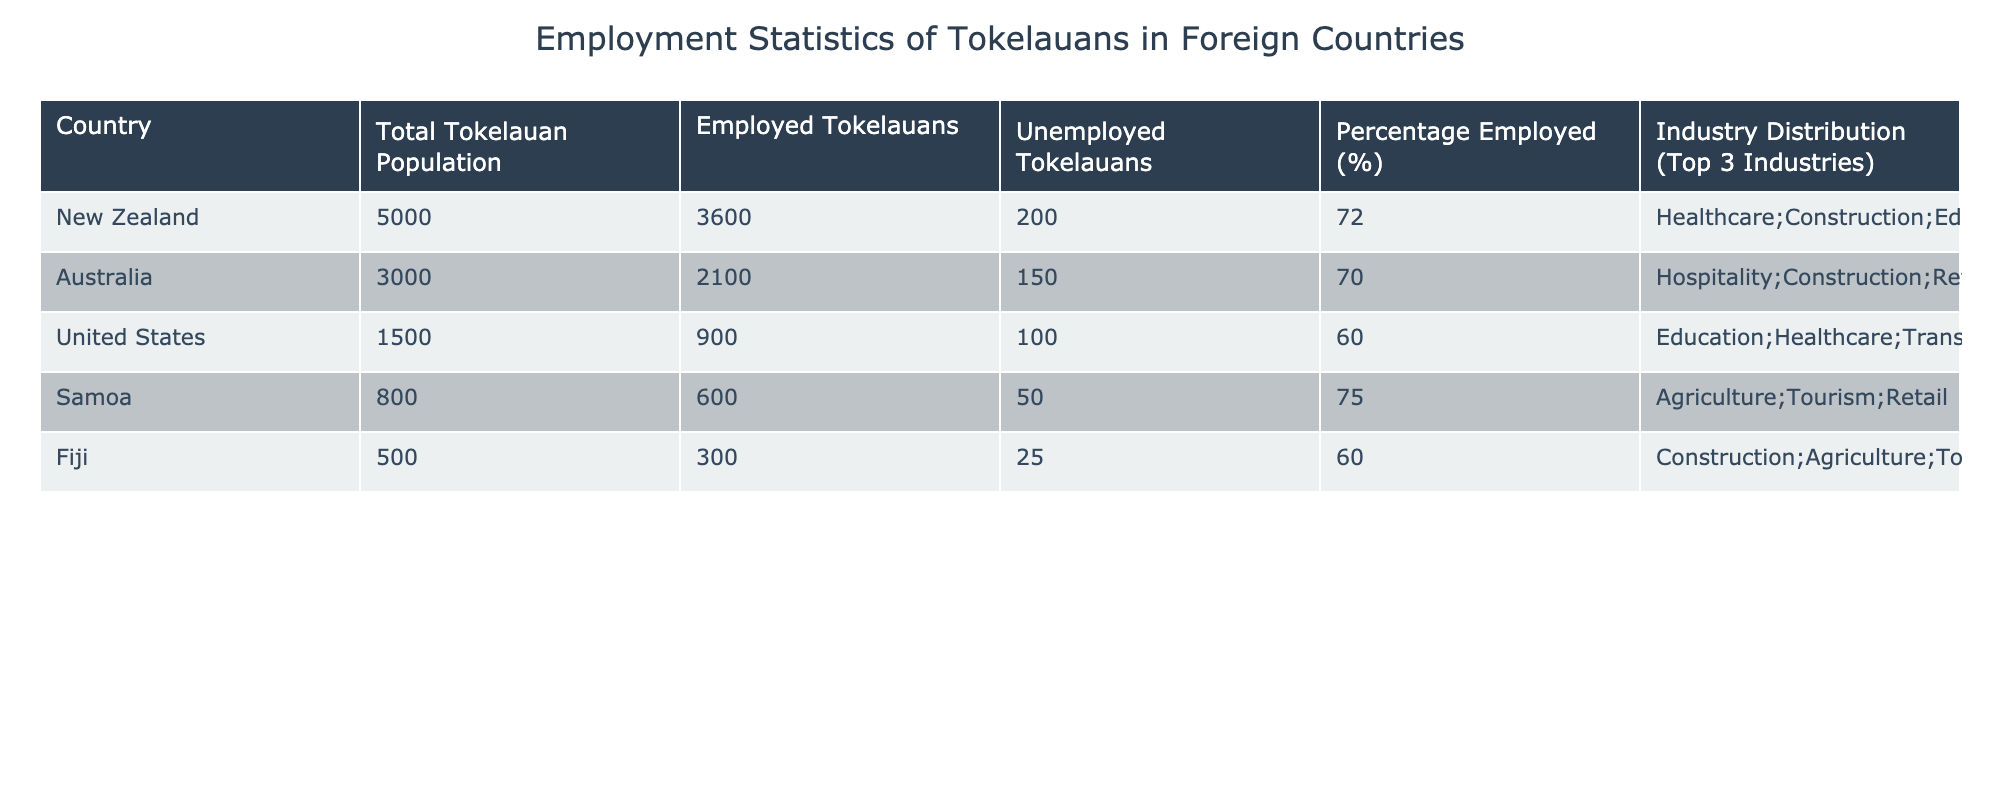What is the employment percentage of Tokelauans in New Zealand? The table shows the employment percentage of Tokelauans in New Zealand as 72%. This value can be directly retrieved from the table under the "Percentage Employed (%)" column for New Zealand.
Answer: 72% Which country has the highest number of employed Tokelauans? From the table, New Zealand has the highest number of employed Tokelauans at 3600. This is found in the "Employed Tokelauans" column and is the largest value when compared to other countries listed.
Answer: New Zealand What is the total number of Tokelauans employed across all countries listed? To find the total number of employed Tokelauans, we add the values from the "Employed Tokelauans" column: 3600 (New Zealand) + 2100 (Australia) + 900 (United States) + 600 (Samoa) + 300 (Fiji) = 7200.
Answer: 7200 Is there any country where the unemployment rate of Tokelauans is below 70%? Looking at the "Percentage Employed (%)" column, Samoa has a percentage of 75%, indicating that it does not have an unemployment rate below 70%. However, the United States has a percentage of 60%, meaning there is indeed a country (the US) where the unemployment rate is below 70%.
Answer: Yes What is the average employment percentage of Tokelauans in the listed countries? To calculate the average, sum the employment percentages: (72 + 70 + 60 + 75 + 60) = 337. Then divide by the number of countries (5): 337 / 5 = 67.4%.
Answer: 67.4% Which industry employs the most Tokelauans in Australia? The table lists the top three industries in Australia as Hospitality, Construction, and Retail. Based on the data provided, Hospitality is the first industry listed, indicating it employs the most Tokelauans in Australia.
Answer: Hospitality How many Tokelauans are unemployed in Fiji? The table specifies that there are 25 unemployed Tokelauans in Fiji, which can be directly referenced from the "Unemployed Tokelauans" column for Fiji.
Answer: 25 Is the employment percentage of Tokelauans in the United States higher than that in Fiji? The employment percentage for Tokelauans in the United States is 60%, while in Fiji it is 60% as well. Thus, they are equal but not higher.
Answer: No Which country has the lowest employment rate for Tokelauans? By examining the "Percentage Employed (%)" column, the United States shows the lowest rate at just 60%. This is the smallest value in that column across all the countries listed.
Answer: United States 